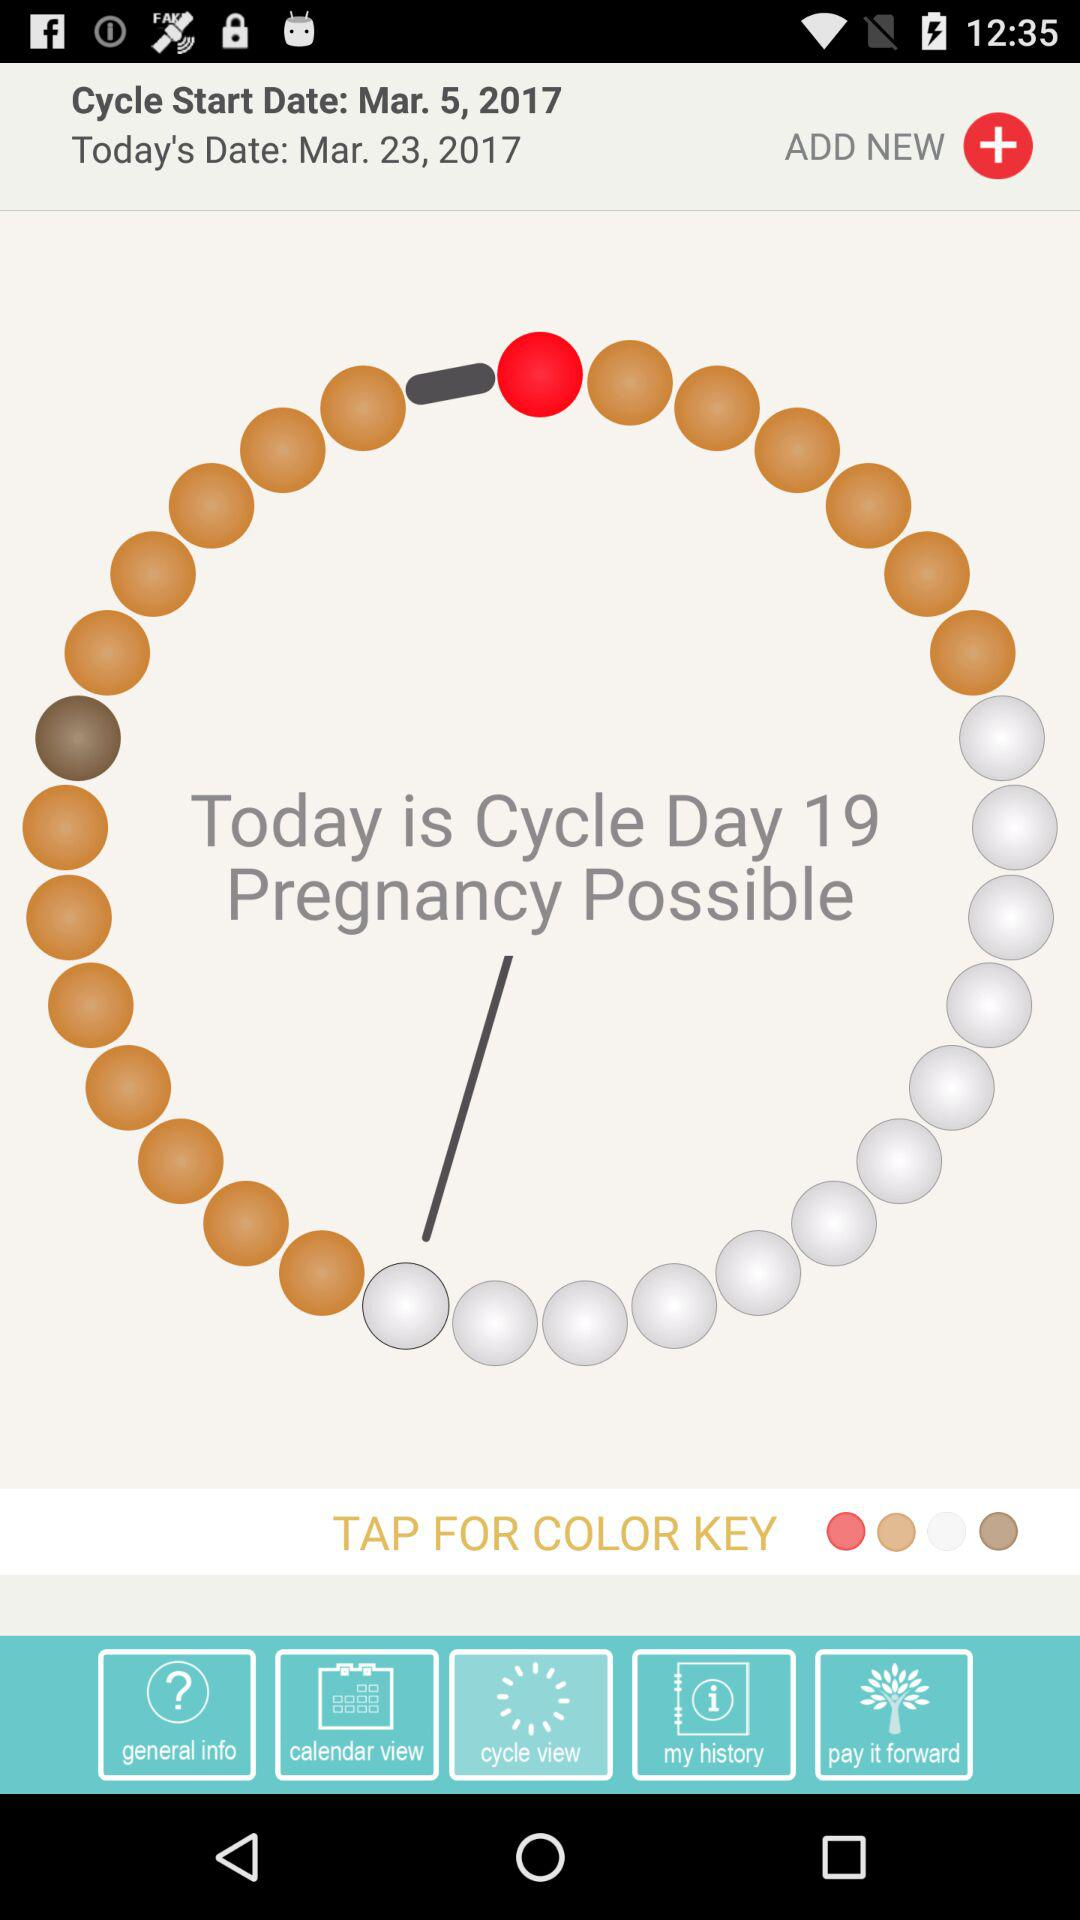Which tab is selected? The selected tab is "cycle view". 